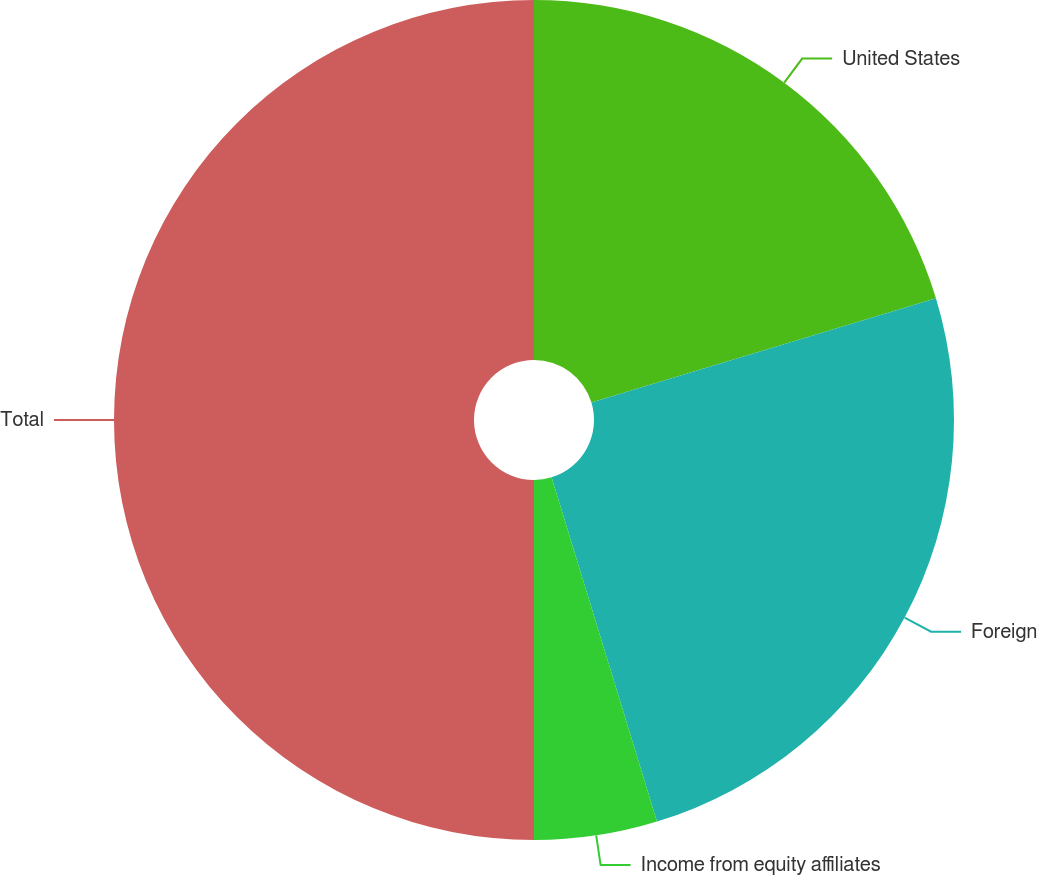Convert chart. <chart><loc_0><loc_0><loc_500><loc_500><pie_chart><fcel>United States<fcel>Foreign<fcel>Income from equity affiliates<fcel>Total<nl><fcel>20.32%<fcel>24.95%<fcel>4.73%<fcel>50.0%<nl></chart> 